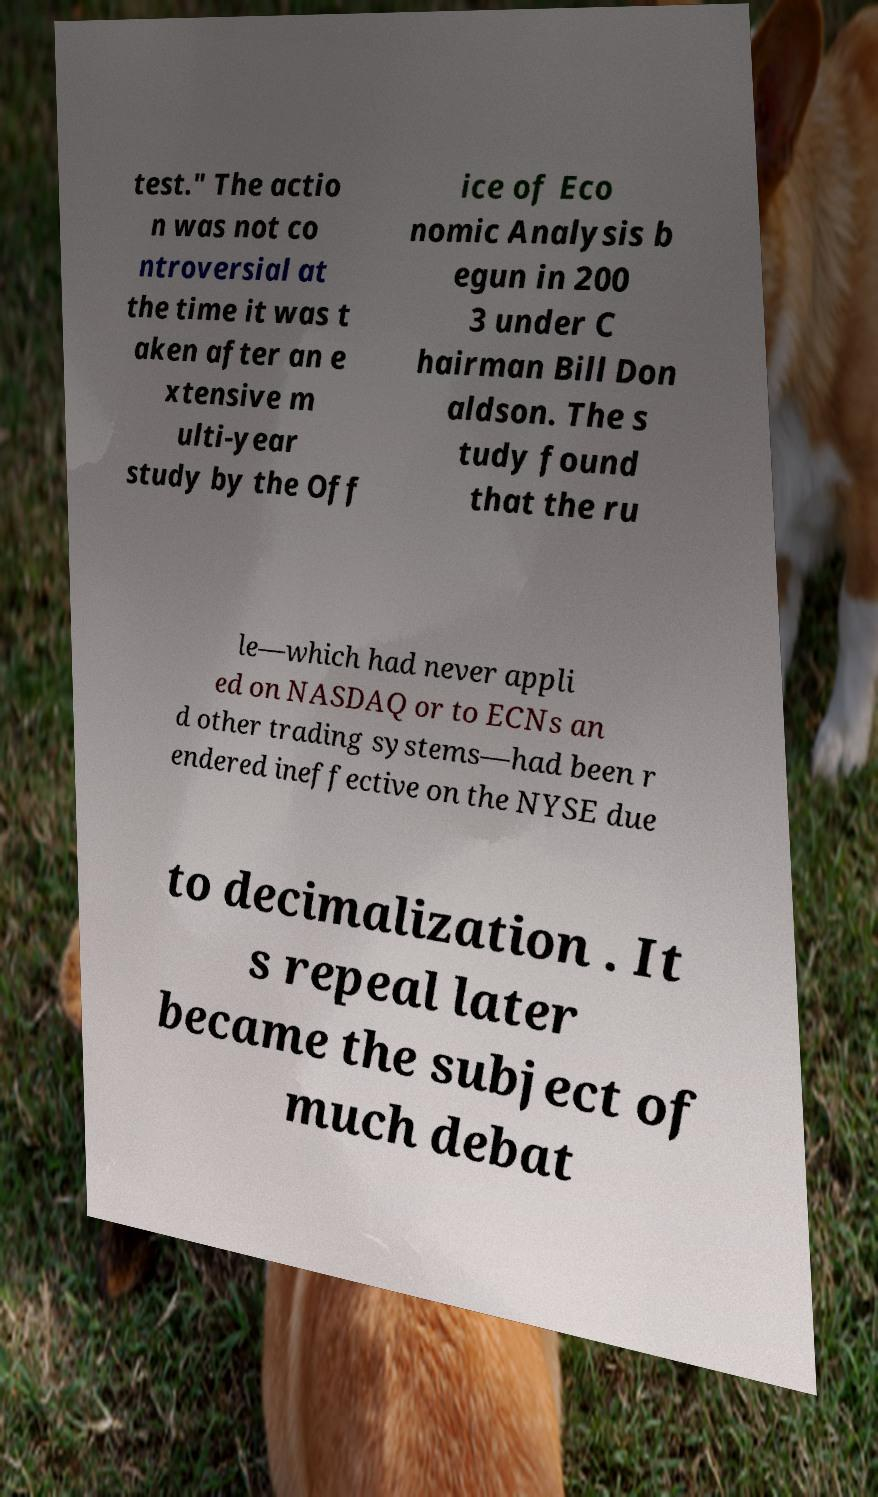Could you extract and type out the text from this image? test." The actio n was not co ntroversial at the time it was t aken after an e xtensive m ulti-year study by the Off ice of Eco nomic Analysis b egun in 200 3 under C hairman Bill Don aldson. The s tudy found that the ru le—which had never appli ed on NASDAQ or to ECNs an d other trading systems—had been r endered ineffective on the NYSE due to decimalization . It s repeal later became the subject of much debat 